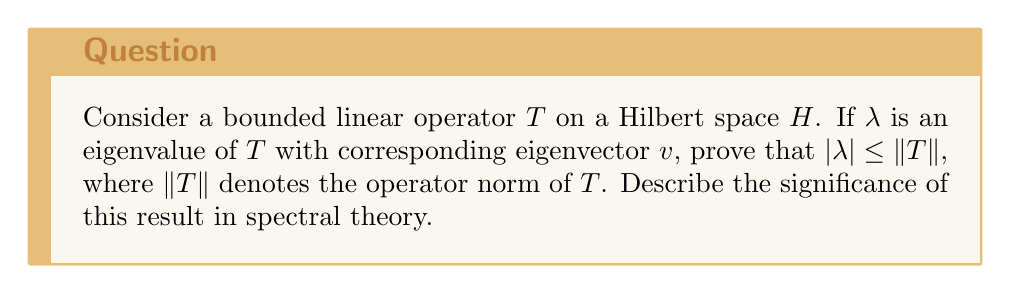Show me your answer to this math problem. Let's approach this proof step-by-step:

1) By definition, if $\lambda$ is an eigenvalue of $T$ with eigenvector $v$, then:
   $$Tv = \lambda v$$

2) Take the norm of both sides:
   $$\|Tv\| = |\lambda| \|v\|$$

3) By the definition of the operator norm, we know that for any vector $x$:
   $$\|Tx\| \leq \|T\| \|x\|$$

4) Applying this to our eigenvector $v$:
   $$\|Tv\| \leq \|T\| \|v\|$$

5) Combining steps 2 and 4:
   $$|\lambda| \|v\| = \|Tv\| \leq \|T\| \|v\|$$

6) Since $v$ is an eigenvector, it's non-zero. We can divide both sides by $\|v\|$:
   $$|\lambda| \leq \|T\|$$

This result is significant in spectral theory because:

a) It provides an upper bound for all eigenvalues of $T$.
b) It shows that the spectral radius (the maximum absolute value of eigenvalues) is always less than or equal to the operator norm.
c) It connects the algebraic properties of $T$ (its eigenvalues) with its analytic properties (its norm).
d) It's a key component in understanding the spectrum of bounded linear operators.
Answer: $|\lambda| \leq \|T\|$ 